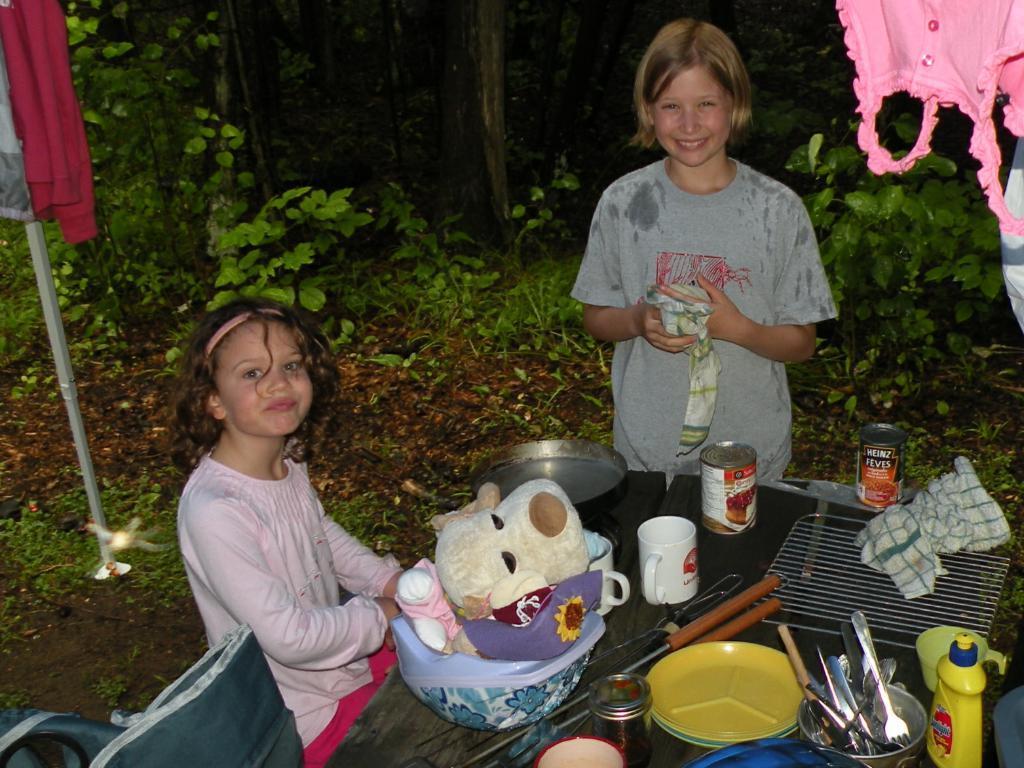How would you summarize this image in a sentence or two? In this image we can see two people smiling, before them there is a table and we can see vessels, soft toys, tins, mug, plates, spoons and bottles placed on the table. We can see a cloth and a tray. At the top there are clothes. In the background there are trees. 